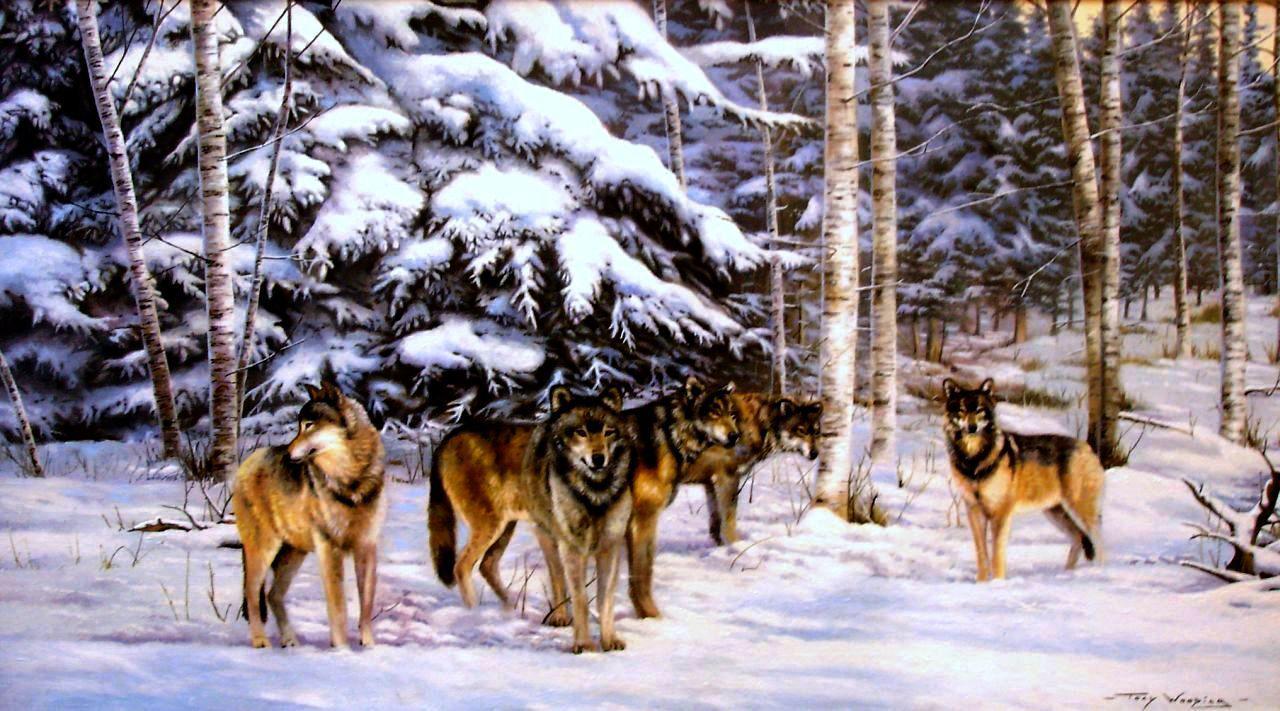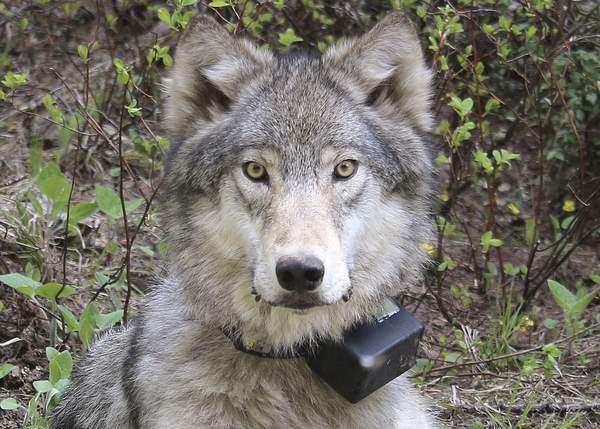The first image is the image on the left, the second image is the image on the right. Examine the images to the left and right. Is the description "An image shows a row of three wolves with heads that are not raised high, and two of the wolves have open mouths." accurate? Answer yes or no. No. The first image is the image on the left, the second image is the image on the right. Given the left and right images, does the statement "There are exactly three wolves standing next to each-other in the image on the left." hold true? Answer yes or no. No. 